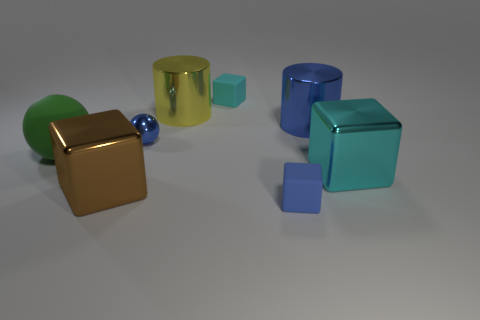How many objects are small blue objects or tiny purple metal blocks?
Offer a terse response. 2. Does the small object that is in front of the large brown metallic cube have the same material as the big brown block?
Your response must be concise. No. The green object has what size?
Offer a very short reply. Large. There is a tiny object that is the same color as the small metal ball; what is its shape?
Give a very brief answer. Cube. What number of blocks are either purple rubber objects or brown metallic objects?
Your answer should be very brief. 1. Is the number of large balls to the right of the cyan rubber object the same as the number of cyan matte blocks that are behind the large brown block?
Keep it short and to the point. No. The brown thing that is the same shape as the cyan shiny thing is what size?
Provide a succinct answer. Large. There is a rubber thing that is both right of the tiny metal sphere and behind the brown metal block; what is its size?
Offer a terse response. Small. There is a big brown thing; are there any large yellow metallic cylinders behind it?
Make the answer very short. Yes. How many things are either big shiny cubes that are in front of the tiny shiny ball or large cyan metallic objects?
Provide a short and direct response. 2. 